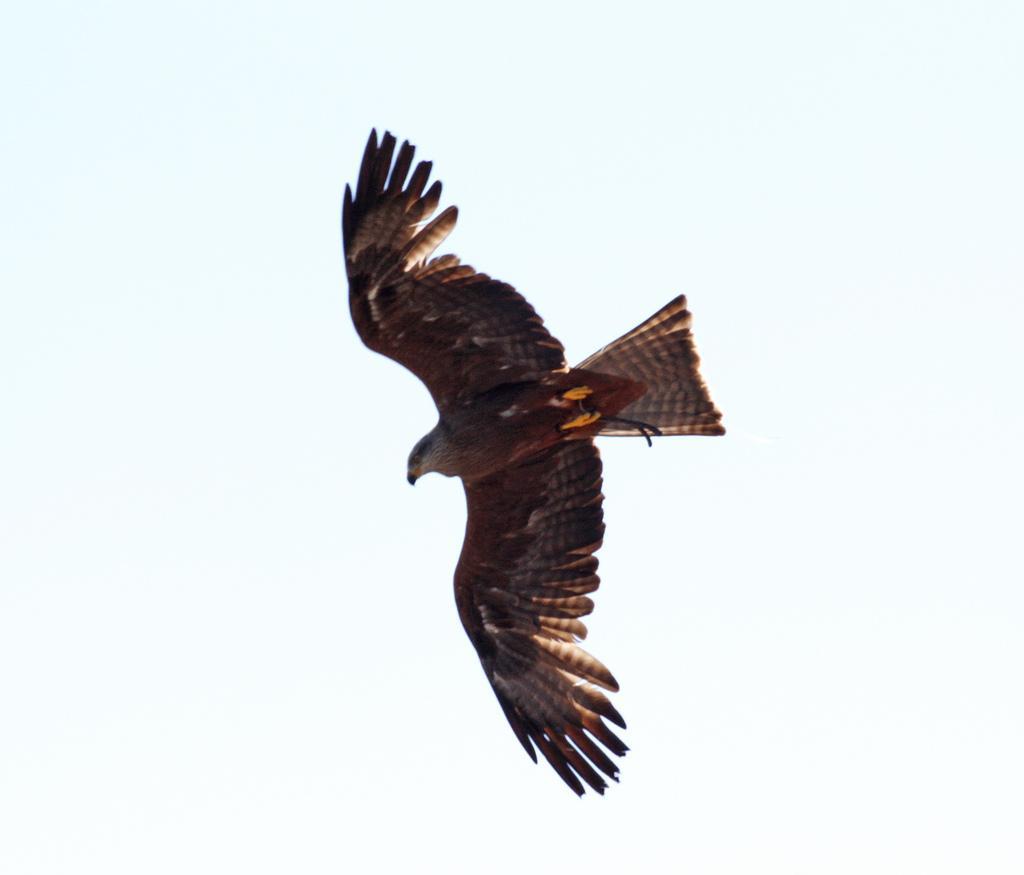In one or two sentences, can you explain what this image depicts? In this picture we can see an eagle flying in the sky. 